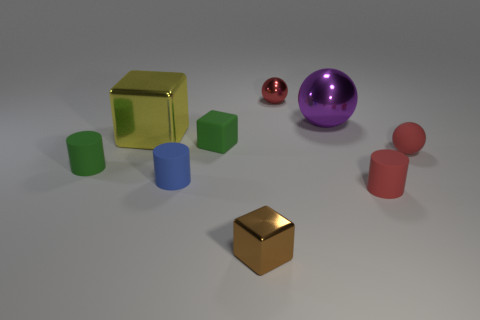There is another tiny sphere that is the same color as the rubber sphere; what is its material?
Offer a very short reply. Metal. What material is the small red thing that is behind the big object that is to the right of the red shiny object?
Your answer should be compact. Metal. There is a small red shiny sphere; how many metallic balls are on the left side of it?
Ensure brevity in your answer.  0. Are there fewer green cubes in front of the purple shiny object than rubber cylinders that are behind the small red cylinder?
Your answer should be compact. Yes. What shape is the tiny metallic thing that is behind the tiny block in front of the small matte thing to the left of the big yellow shiny block?
Keep it short and to the point. Sphere. There is a metallic thing that is both behind the tiny red matte cylinder and in front of the large purple thing; what is its shape?
Keep it short and to the point. Cube. Are there any big yellow cubes that have the same material as the large purple sphere?
Provide a succinct answer. Yes. There is a object that is the same color as the matte cube; what is its size?
Ensure brevity in your answer.  Small. There is a tiny sphere in front of the tiny green rubber cube; what color is it?
Offer a very short reply. Red. Is the shape of the brown shiny object the same as the green matte thing that is to the left of the blue cylinder?
Offer a terse response. No. 